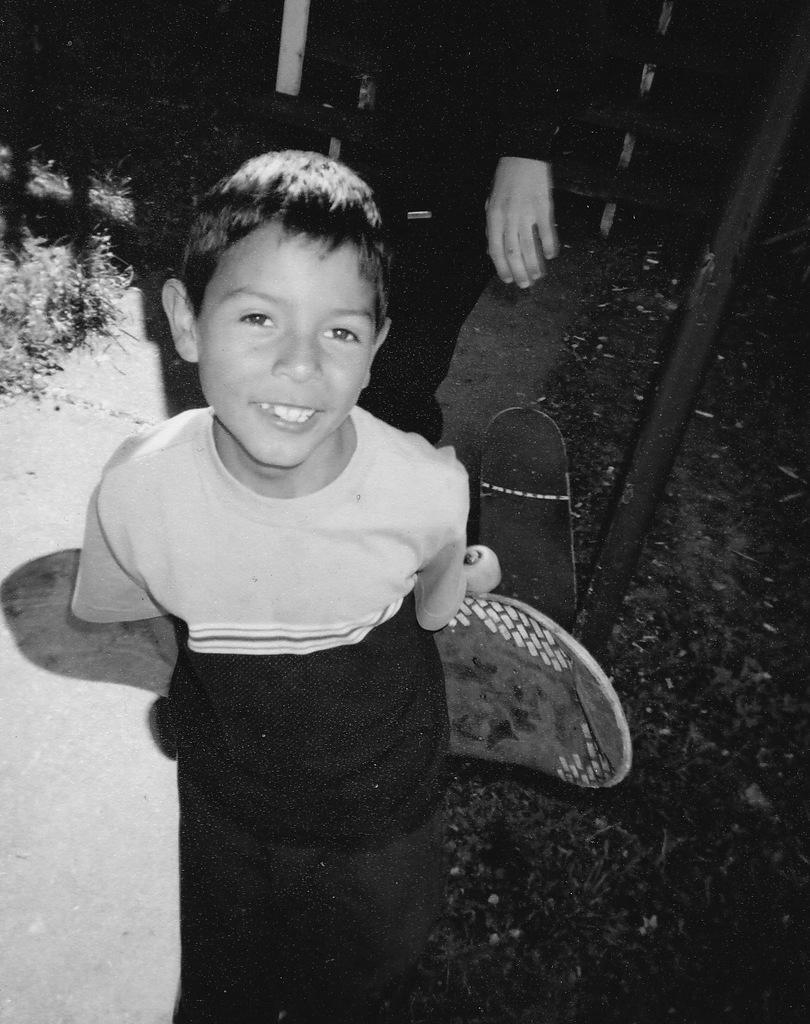Can you describe this image briefly? In this black and white picture there is a boy standing. He is holding a skateboard in his hand. Behind him there is another person. Beside that person there is a skateboard on the ground. To the left there are plants on the ground. 